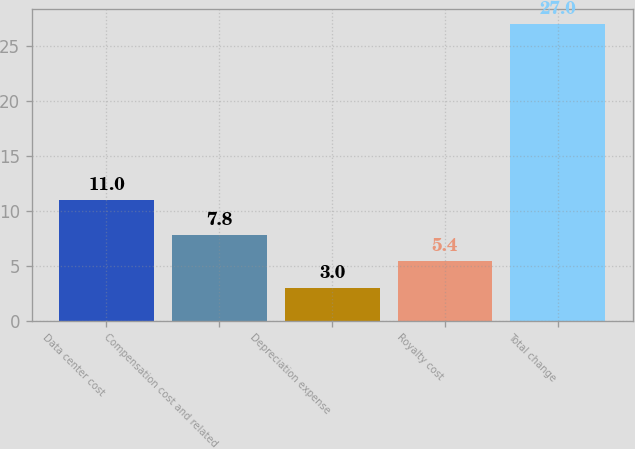Convert chart to OTSL. <chart><loc_0><loc_0><loc_500><loc_500><bar_chart><fcel>Data center cost<fcel>Compensation cost and related<fcel>Depreciation expense<fcel>Royalty cost<fcel>Total change<nl><fcel>11<fcel>7.8<fcel>3<fcel>5.4<fcel>27<nl></chart> 